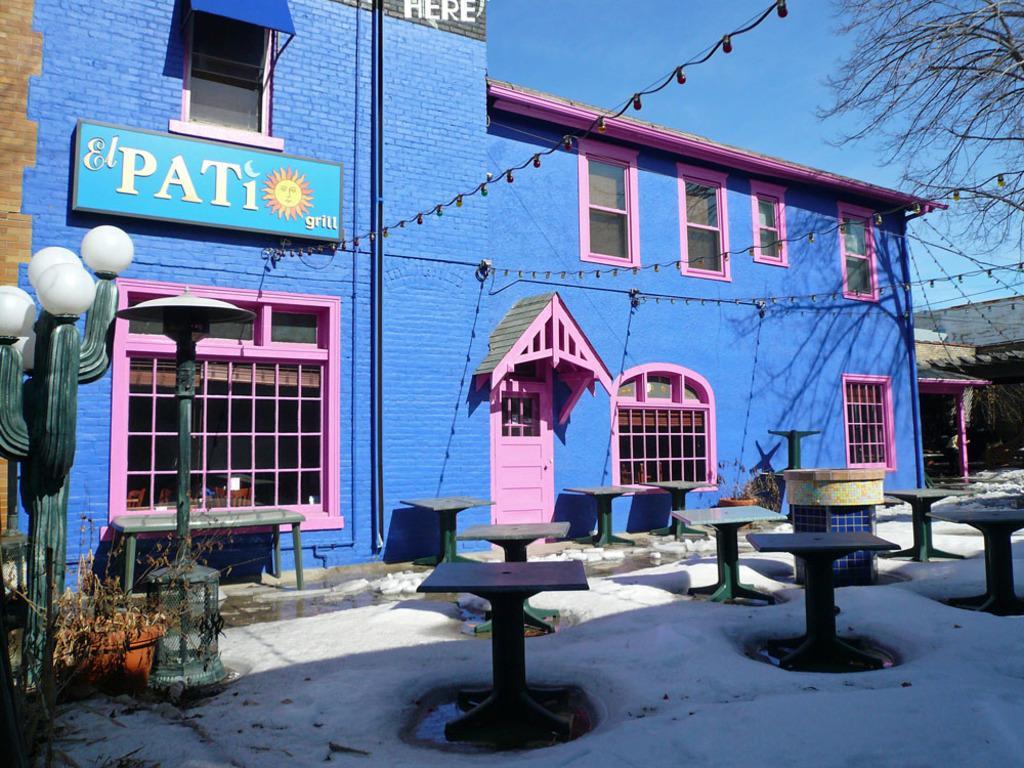Could you give a brief overview of what you see in this image? In the middle of the picture, we see tables and benches. Beside that, we see a building in blue and pink color. We even see pink door and windows. On the left side, we see light poles. On the right side, we see a tree and a building in white color. At the top of the picture, we see the sky and the lights. 